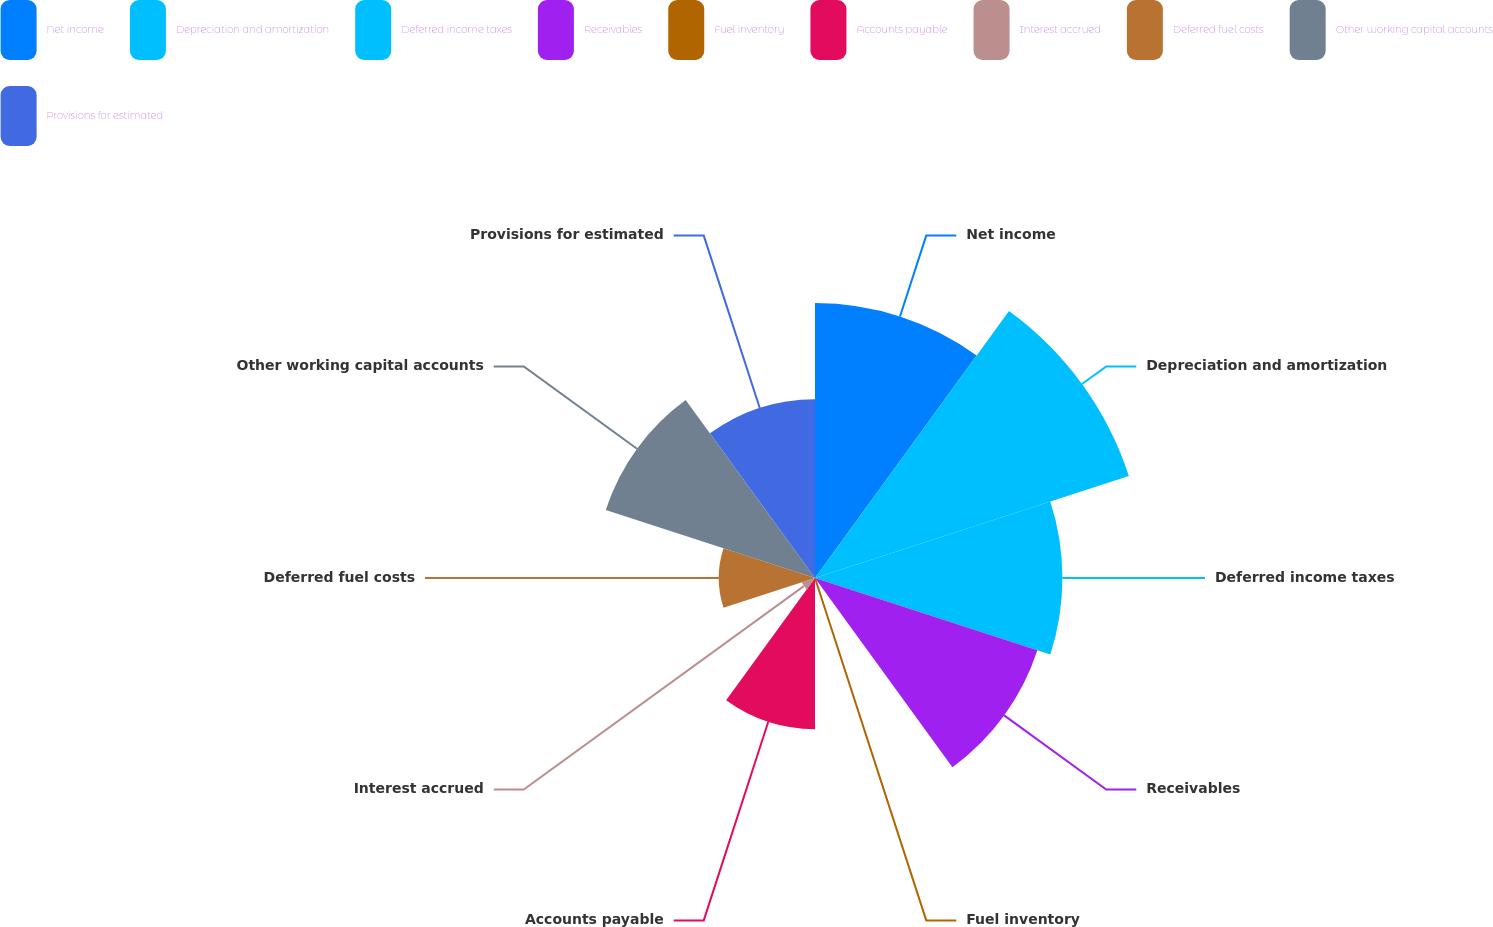Convert chart. <chart><loc_0><loc_0><loc_500><loc_500><pie_chart><fcel>Net income<fcel>Depreciation and amortization<fcel>Deferred income taxes<fcel>Receivables<fcel>Fuel inventory<fcel>Accounts payable<fcel>Interest accrued<fcel>Deferred fuel costs<fcel>Other working capital accounts<fcel>Provisions for estimated<nl><fcel>15.75%<fcel>18.9%<fcel>14.17%<fcel>13.39%<fcel>0.0%<fcel>8.66%<fcel>0.79%<fcel>5.51%<fcel>12.6%<fcel>10.24%<nl></chart> 